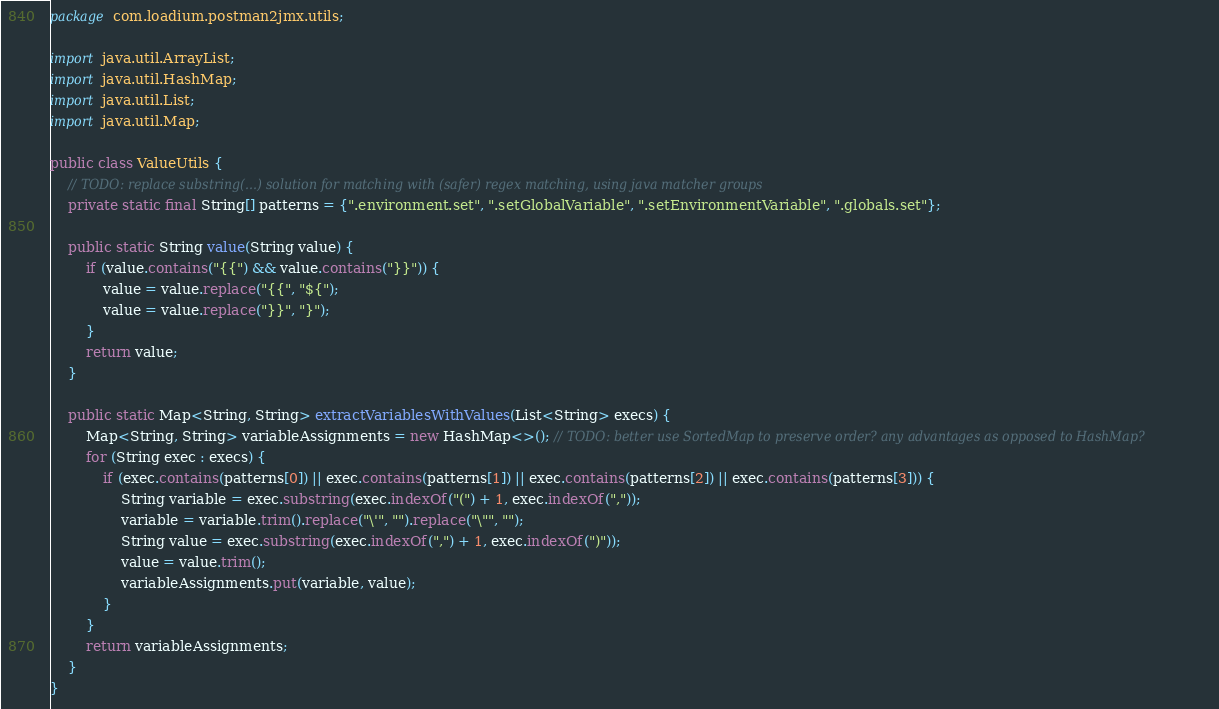<code> <loc_0><loc_0><loc_500><loc_500><_Java_>package com.loadium.postman2jmx.utils;

import java.util.ArrayList;
import java.util.HashMap;
import java.util.List;
import java.util.Map;

public class ValueUtils {
    // TODO: replace substring(...) solution for matching with (safer) regex matching, using java matcher groups
    private static final String[] patterns = {".environment.set", ".setGlobalVariable", ".setEnvironmentVariable", ".globals.set"};

    public static String value(String value) {
        if (value.contains("{{") && value.contains("}}")) {
            value = value.replace("{{", "${");
            value = value.replace("}}", "}");
        }
        return value;
    }

    public static Map<String, String> extractVariablesWithValues(List<String> execs) {
        Map<String, String> variableAssignments = new HashMap<>(); // TODO: better use SortedMap to preserve order? any advantages as opposed to HashMap?
        for (String exec : execs) {
            if (exec.contains(patterns[0]) || exec.contains(patterns[1]) || exec.contains(patterns[2]) || exec.contains(patterns[3])) {
                String variable = exec.substring(exec.indexOf("(") + 1, exec.indexOf(","));
                variable = variable.trim().replace("\'", "").replace("\"", "");
                String value = exec.substring(exec.indexOf(",") + 1, exec.indexOf(")"));
                value = value.trim();
                variableAssignments.put(variable, value);
            }
        }
        return variableAssignments;
    }
}
</code> 